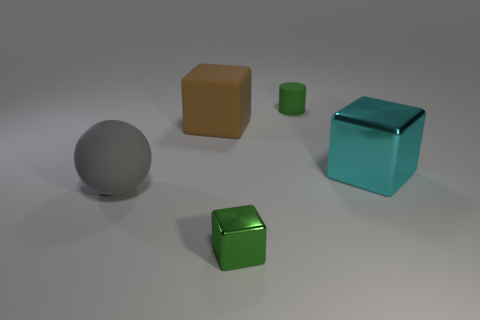Add 1 small shiny things. How many objects exist? 6 Subtract all shiny cubes. How many cubes are left? 1 Subtract all cyan blocks. How many blocks are left? 2 Subtract 0 brown balls. How many objects are left? 5 Subtract all blocks. How many objects are left? 2 Subtract 2 cubes. How many cubes are left? 1 Subtract all gray cylinders. Subtract all green cubes. How many cylinders are left? 1 Subtract all blue cubes. How many cyan spheres are left? 0 Subtract all green cubes. Subtract all gray matte balls. How many objects are left? 3 Add 1 big brown rubber things. How many big brown rubber things are left? 2 